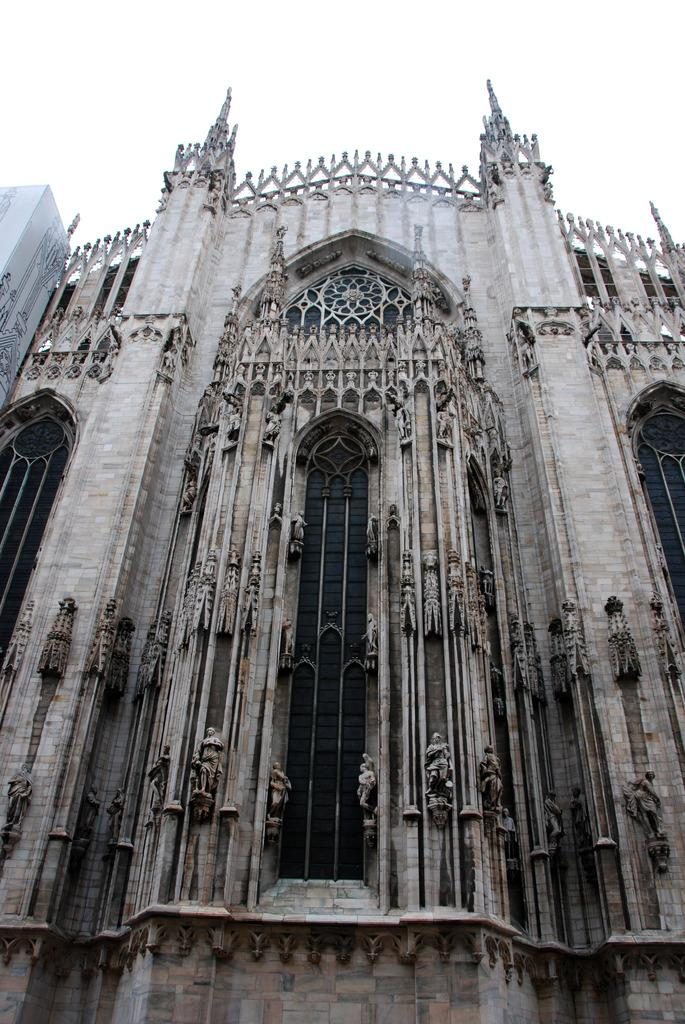What type of structure is present in the image? There is a building in the image. What decorative elements can be seen on the building? The building has sculptures. Can you describe the object on the left side of the image? There is a white colored object on the left side of the image. What is visible in the background of the image? The sky is visible in the image. What type of religious ceremony is taking place in the image? There is no indication of a religious ceremony in the image; it primarily features a building with sculptures and a white colored object on the left side. How many tomatoes are hanging from the building in the image? There are no tomatoes present in the image. 